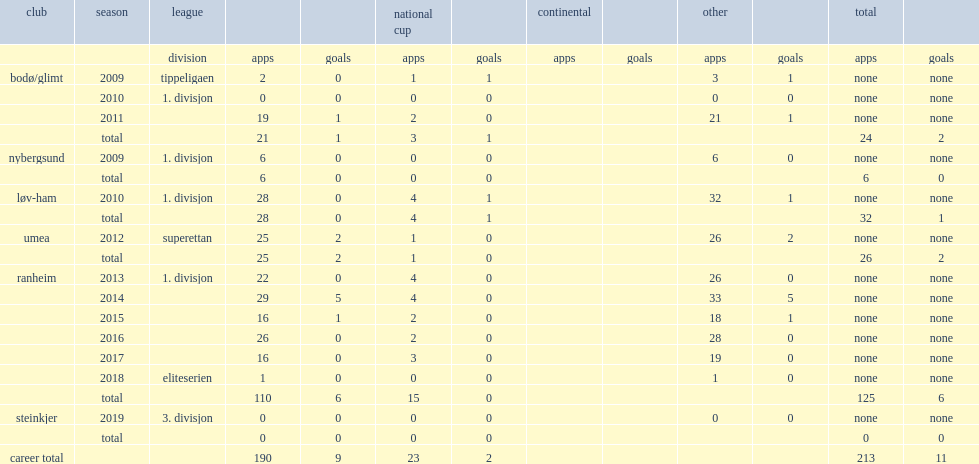In 2012-season, which league was eek with? Superettan. 